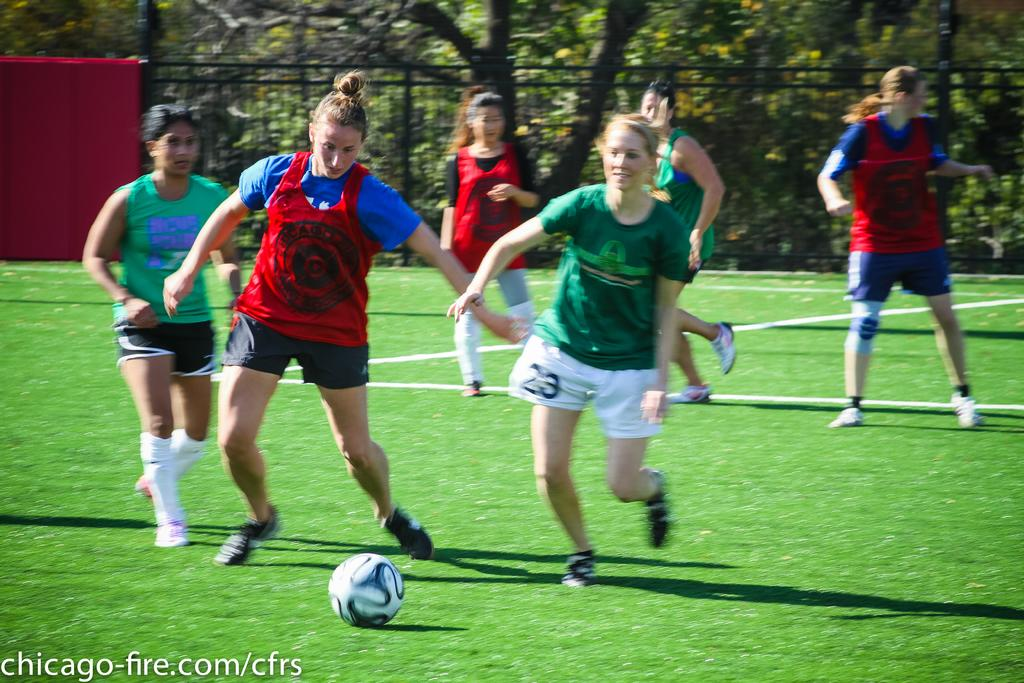<image>
Render a clear and concise summary of the photo. Young women playing soccer in red and green teams, one girl is number 23. 